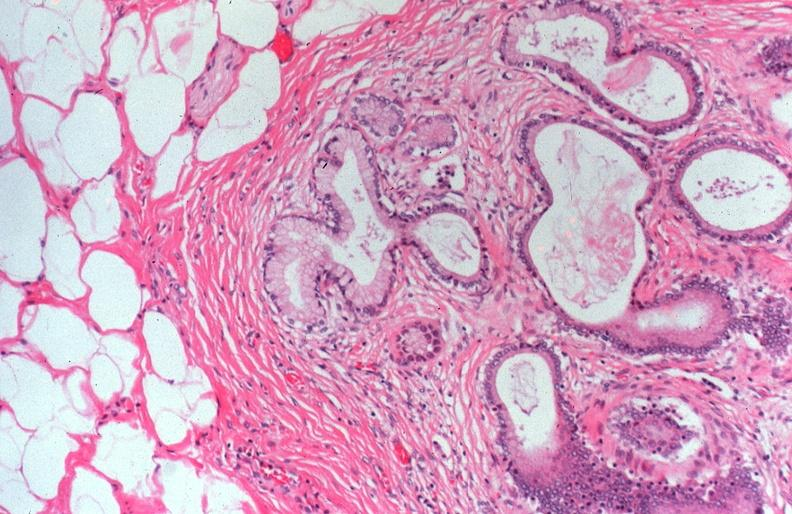does this image show cystic fibrosis?
Answer the question using a single word or phrase. Yes 